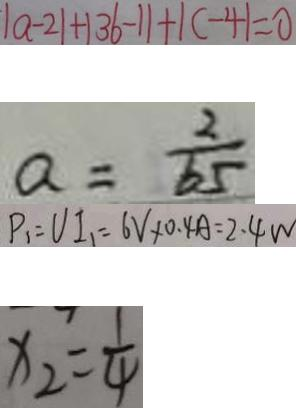Convert formula to latex. <formula><loc_0><loc_0><loc_500><loc_500>\vert a - 2 \vert + \vert 3 6 - 1 \vert + \vert c - 4 \vert = 0 
 a = \frac { 2 } { 6 5 } 
 P _ { 1 } = V I _ { 1 } = 6 V \times 0 . 4 A = 2 . 4 w 
 x _ { 2 } = \frac { 1 } { 4 }</formula> 